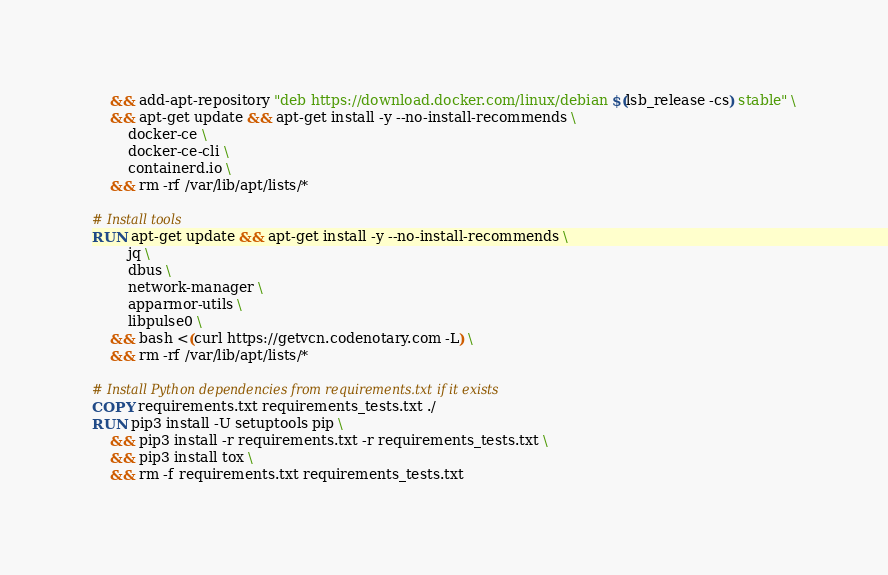<code> <loc_0><loc_0><loc_500><loc_500><_Dockerfile_>    && add-apt-repository "deb https://download.docker.com/linux/debian $(lsb_release -cs) stable" \
    && apt-get update && apt-get install -y --no-install-recommends \
        docker-ce \
        docker-ce-cli \
        containerd.io \
    && rm -rf /var/lib/apt/lists/*

# Install tools
RUN apt-get update && apt-get install -y --no-install-recommends \
        jq \
        dbus \
        network-manager \
        apparmor-utils \
        libpulse0 \
    && bash <(curl https://getvcn.codenotary.com -L) \
    && rm -rf /var/lib/apt/lists/*

# Install Python dependencies from requirements.txt if it exists
COPY requirements.txt requirements_tests.txt ./
RUN pip3 install -U setuptools pip \
    && pip3 install -r requirements.txt -r requirements_tests.txt \
    && pip3 install tox \
    && rm -f requirements.txt requirements_tests.txt
</code> 